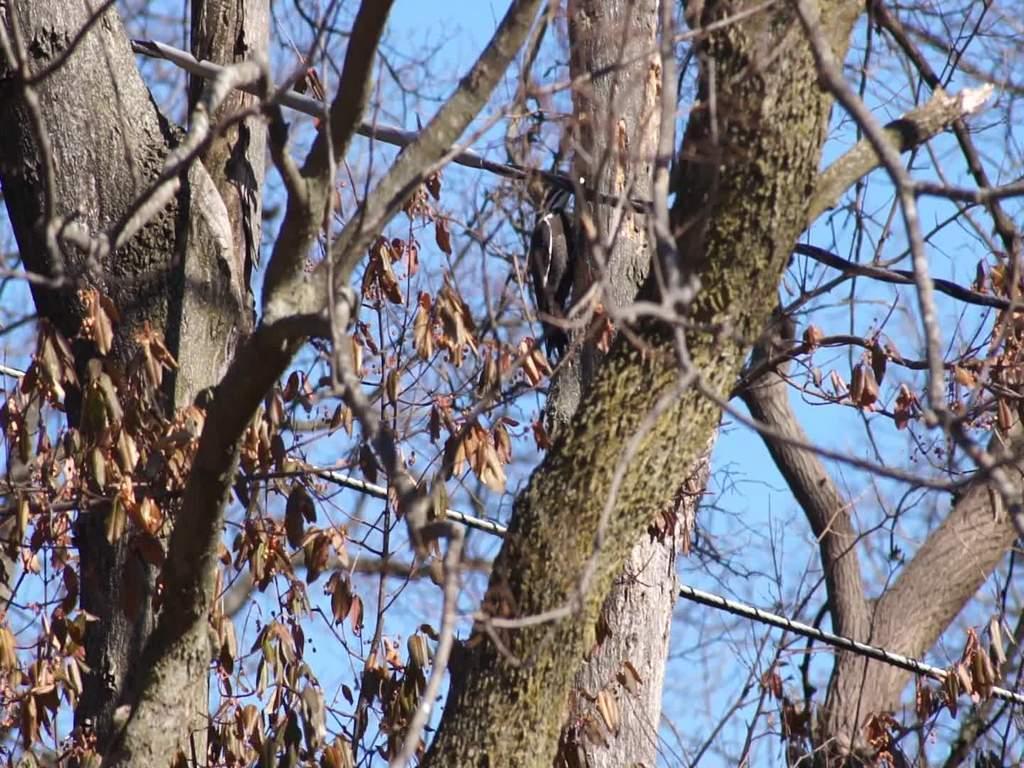How would you summarize this image in a sentence or two? In the middle of the image we can see a bird, and we can find few trees and cables. 